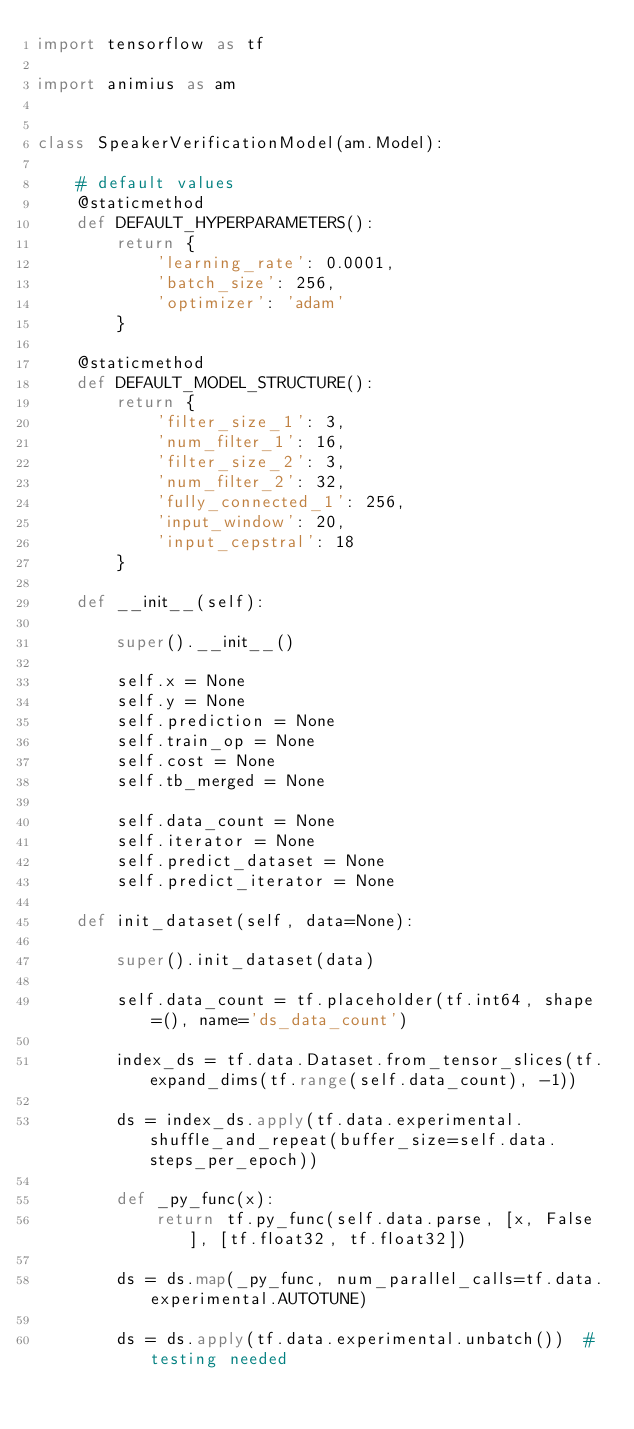Convert code to text. <code><loc_0><loc_0><loc_500><loc_500><_Python_>import tensorflow as tf

import animius as am


class SpeakerVerificationModel(am.Model):

    # default values
    @staticmethod
    def DEFAULT_HYPERPARAMETERS():
        return {
            'learning_rate': 0.0001,
            'batch_size': 256,
            'optimizer': 'adam'
        }

    @staticmethod
    def DEFAULT_MODEL_STRUCTURE():
        return {
            'filter_size_1': 3,
            'num_filter_1': 16,
            'filter_size_2': 3,
            'num_filter_2': 32,
            'fully_connected_1': 256,
            'input_window': 20,
            'input_cepstral': 18
        }

    def __init__(self):

        super().__init__()

        self.x = None
        self.y = None
        self.prediction = None
        self.train_op = None
        self.cost = None
        self.tb_merged = None

        self.data_count = None
        self.iterator = None
        self.predict_dataset = None
        self.predict_iterator = None

    def init_dataset(self, data=None):

        super().init_dataset(data)

        self.data_count = tf.placeholder(tf.int64, shape=(), name='ds_data_count')

        index_ds = tf.data.Dataset.from_tensor_slices(tf.expand_dims(tf.range(self.data_count), -1))

        ds = index_ds.apply(tf.data.experimental.shuffle_and_repeat(buffer_size=self.data.steps_per_epoch))

        def _py_func(x):
            return tf.py_func(self.data.parse, [x, False], [tf.float32, tf.float32])

        ds = ds.map(_py_func, num_parallel_calls=tf.data.experimental.AUTOTUNE)

        ds = ds.apply(tf.data.experimental.unbatch())  # testing needed
</code> 